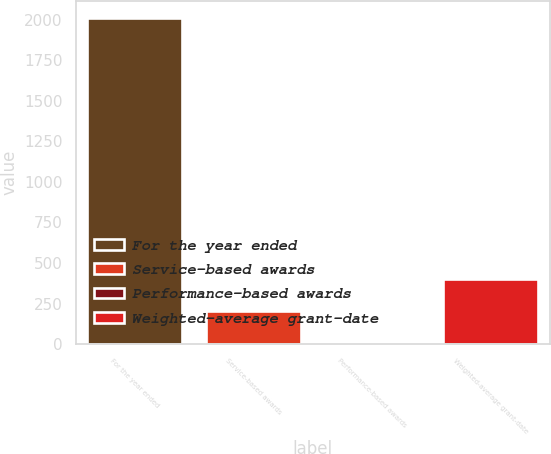<chart> <loc_0><loc_0><loc_500><loc_500><bar_chart><fcel>For the year ended<fcel>Service-based awards<fcel>Performance-based awards<fcel>Weighted-average grant-date<nl><fcel>2012<fcel>202.91<fcel>1.9<fcel>403.92<nl></chart> 